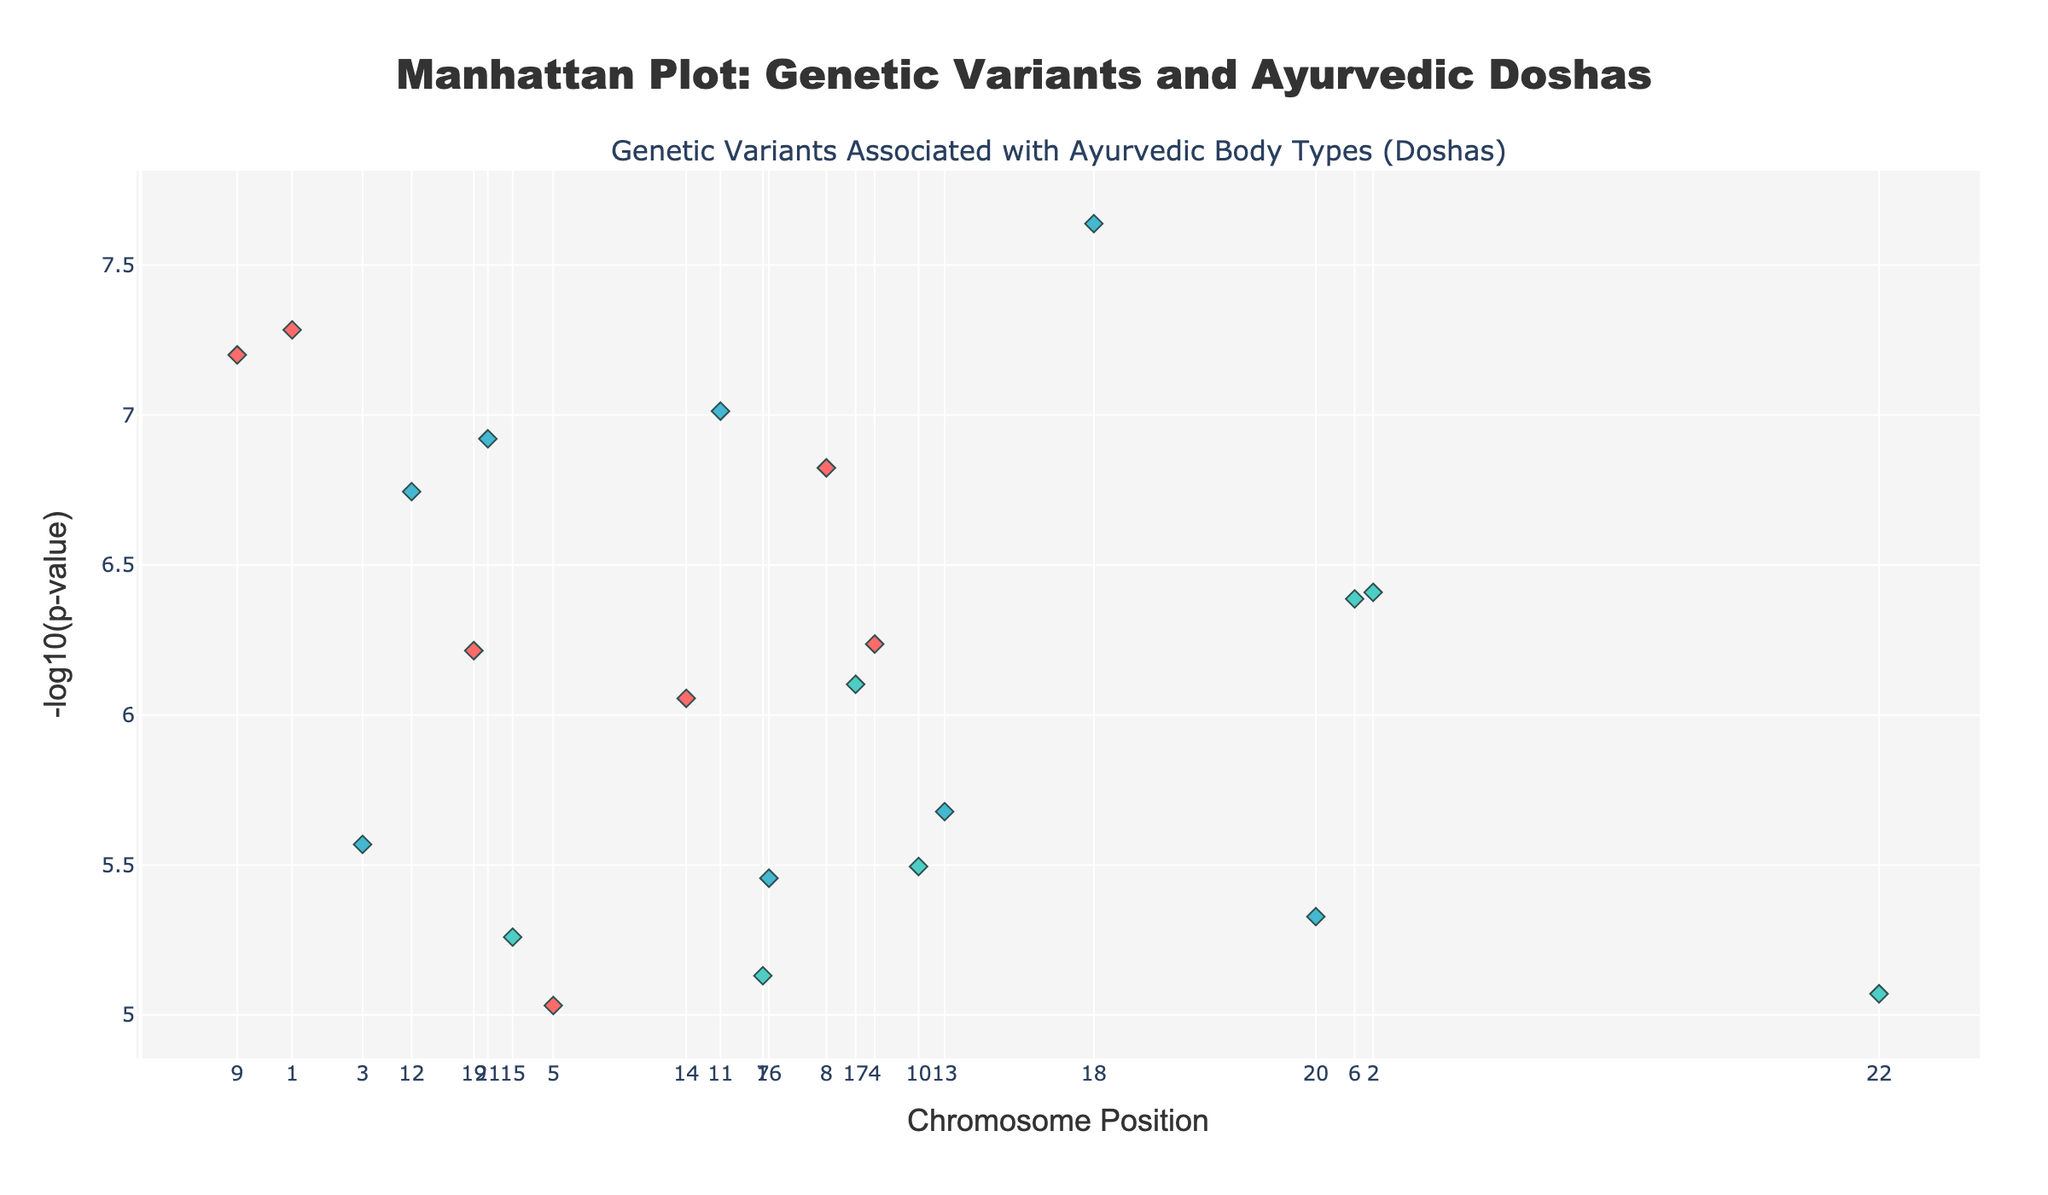What is the title of the plot? The text at the top of the plot displays the title.
Answer: Manhattan Plot: Genetic Variants and Ayurvedic Doshas Which axis represents the chromosomal positions? The title and labels of the axis at the bottom indicate that it represents chromosomal positions.
Answer: The x-axis What is represented by the y-axis? The title and labels of the axis on the left indicate that it shows the negative logarithm of the p-values.
Answer: -log10(p-value) How many genetic variants are associated with the Vata dosha? By counting the points colored specific to Vata in the legend and plot, we find a certain number of variants.
Answer: 7 Which gene has the lowest p-value on Chromosome 1? Look at the points on Chromosome 1 and identify the point with the highest y-value (lowest p-value) and check its annotation.
Answer: MTHFR Which chromosome has the highest number of genetic variants associated with the Kapha dosha? Count the points colored specific to Kapha on each chromosome and identify the chromosome with the most.
Answer: Chromosome 2 Compare the p-values of genes ADIPOQ and PPARG on Chromosome 3 and 8 respectively. Which is more significant? By checking the y-values of the points representing ADIPOQ and PPARG, compare their heights; the higher point is more significant.
Answer: PPARG (higher -log10(p-value)) What are the two genes with p-values closest to 1.8e-7? Identify the points closest to y=-log10(1.8e-7) and check their annotations.
Answer: APOB and PPARG Do any chromosomes have more variants associated with Pitta than with Kapha? Check if any chromosome has more points colored for Pitta than for Kapha.
Answer: No Are there any genetic variants associated with multiple doshas? Look for genetic variants with the same gene name but different Dosha associations.
Answer: Yes, APOE 